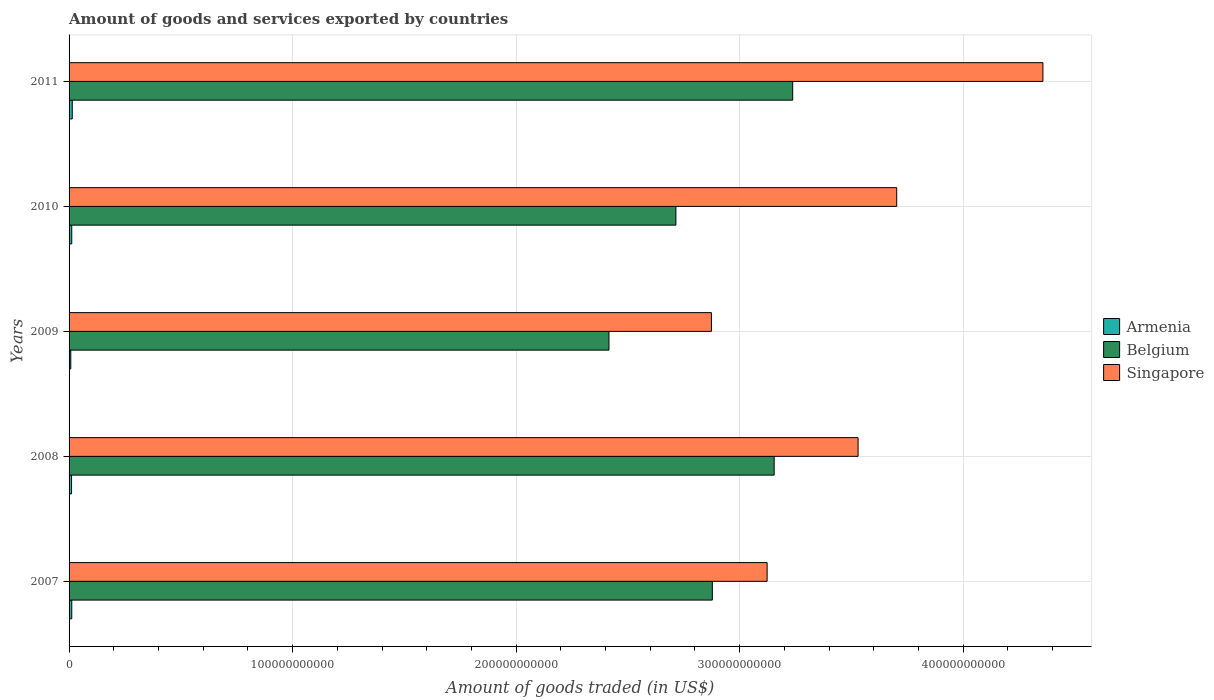How many groups of bars are there?
Keep it short and to the point. 5. Are the number of bars per tick equal to the number of legend labels?
Offer a terse response. Yes. How many bars are there on the 5th tick from the top?
Your answer should be very brief. 3. How many bars are there on the 3rd tick from the bottom?
Provide a short and direct response. 3. What is the total amount of goods and services exported in Belgium in 2008?
Keep it short and to the point. 3.15e+11. Across all years, what is the maximum total amount of goods and services exported in Armenia?
Ensure brevity in your answer.  1.43e+09. Across all years, what is the minimum total amount of goods and services exported in Singapore?
Offer a terse response. 2.87e+11. In which year was the total amount of goods and services exported in Belgium maximum?
Ensure brevity in your answer.  2011. In which year was the total amount of goods and services exported in Belgium minimum?
Provide a succinct answer. 2009. What is the total total amount of goods and services exported in Singapore in the graph?
Your answer should be compact. 1.76e+12. What is the difference between the total amount of goods and services exported in Belgium in 2008 and that in 2010?
Give a very brief answer. 4.40e+1. What is the difference between the total amount of goods and services exported in Armenia in 2010 and the total amount of goods and services exported in Singapore in 2007?
Your answer should be very brief. -3.11e+11. What is the average total amount of goods and services exported in Singapore per year?
Ensure brevity in your answer.  3.52e+11. In the year 2007, what is the difference between the total amount of goods and services exported in Belgium and total amount of goods and services exported in Singapore?
Your response must be concise. -2.45e+1. What is the ratio of the total amount of goods and services exported in Singapore in 2010 to that in 2011?
Provide a succinct answer. 0.85. Is the total amount of goods and services exported in Armenia in 2007 less than that in 2008?
Make the answer very short. No. Is the difference between the total amount of goods and services exported in Belgium in 2009 and 2010 greater than the difference between the total amount of goods and services exported in Singapore in 2009 and 2010?
Your answer should be compact. Yes. What is the difference between the highest and the second highest total amount of goods and services exported in Armenia?
Your response must be concise. 2.27e+08. What is the difference between the highest and the lowest total amount of goods and services exported in Singapore?
Keep it short and to the point. 1.48e+11. Is the sum of the total amount of goods and services exported in Belgium in 2009 and 2010 greater than the maximum total amount of goods and services exported in Singapore across all years?
Keep it short and to the point. Yes. What does the 2nd bar from the top in 2009 represents?
Make the answer very short. Belgium. What does the 3rd bar from the bottom in 2008 represents?
Keep it short and to the point. Singapore. Are all the bars in the graph horizontal?
Provide a short and direct response. Yes. What is the difference between two consecutive major ticks on the X-axis?
Offer a terse response. 1.00e+11. Are the values on the major ticks of X-axis written in scientific E-notation?
Your answer should be compact. No. Does the graph contain any zero values?
Provide a short and direct response. No. Does the graph contain grids?
Offer a very short reply. Yes. Where does the legend appear in the graph?
Provide a short and direct response. Center right. How many legend labels are there?
Offer a very short reply. 3. How are the legend labels stacked?
Ensure brevity in your answer.  Vertical. What is the title of the graph?
Offer a very short reply. Amount of goods and services exported by countries. What is the label or title of the X-axis?
Provide a short and direct response. Amount of goods traded (in US$). What is the Amount of goods traded (in US$) of Armenia in 2007?
Keep it short and to the point. 1.20e+09. What is the Amount of goods traded (in US$) in Belgium in 2007?
Your answer should be compact. 2.88e+11. What is the Amount of goods traded (in US$) of Singapore in 2007?
Make the answer very short. 3.12e+11. What is the Amount of goods traded (in US$) in Armenia in 2008?
Provide a succinct answer. 1.11e+09. What is the Amount of goods traded (in US$) of Belgium in 2008?
Keep it short and to the point. 3.15e+11. What is the Amount of goods traded (in US$) of Singapore in 2008?
Your response must be concise. 3.53e+11. What is the Amount of goods traded (in US$) in Armenia in 2009?
Your answer should be compact. 7.74e+08. What is the Amount of goods traded (in US$) of Belgium in 2009?
Give a very brief answer. 2.42e+11. What is the Amount of goods traded (in US$) in Singapore in 2009?
Offer a terse response. 2.87e+11. What is the Amount of goods traded (in US$) in Armenia in 2010?
Your response must be concise. 1.20e+09. What is the Amount of goods traded (in US$) of Belgium in 2010?
Offer a very short reply. 2.71e+11. What is the Amount of goods traded (in US$) of Singapore in 2010?
Offer a very short reply. 3.70e+11. What is the Amount of goods traded (in US$) of Armenia in 2011?
Offer a terse response. 1.43e+09. What is the Amount of goods traded (in US$) of Belgium in 2011?
Offer a terse response. 3.24e+11. What is the Amount of goods traded (in US$) of Singapore in 2011?
Make the answer very short. 4.36e+11. Across all years, what is the maximum Amount of goods traded (in US$) in Armenia?
Give a very brief answer. 1.43e+09. Across all years, what is the maximum Amount of goods traded (in US$) in Belgium?
Make the answer very short. 3.24e+11. Across all years, what is the maximum Amount of goods traded (in US$) of Singapore?
Offer a very short reply. 4.36e+11. Across all years, what is the minimum Amount of goods traded (in US$) in Armenia?
Offer a terse response. 7.74e+08. Across all years, what is the minimum Amount of goods traded (in US$) of Belgium?
Offer a very short reply. 2.42e+11. Across all years, what is the minimum Amount of goods traded (in US$) in Singapore?
Your answer should be compact. 2.87e+11. What is the total Amount of goods traded (in US$) of Armenia in the graph?
Make the answer very short. 5.71e+09. What is the total Amount of goods traded (in US$) of Belgium in the graph?
Ensure brevity in your answer.  1.44e+12. What is the total Amount of goods traded (in US$) in Singapore in the graph?
Your response must be concise. 1.76e+12. What is the difference between the Amount of goods traded (in US$) in Armenia in 2007 and that in 2008?
Offer a terse response. 9.79e+07. What is the difference between the Amount of goods traded (in US$) of Belgium in 2007 and that in 2008?
Your answer should be very brief. -2.77e+1. What is the difference between the Amount of goods traded (in US$) of Singapore in 2007 and that in 2008?
Keep it short and to the point. -4.07e+1. What is the difference between the Amount of goods traded (in US$) in Armenia in 2007 and that in 2009?
Ensure brevity in your answer.  4.31e+08. What is the difference between the Amount of goods traded (in US$) in Belgium in 2007 and that in 2009?
Keep it short and to the point. 4.62e+1. What is the difference between the Amount of goods traded (in US$) in Singapore in 2007 and that in 2009?
Provide a succinct answer. 2.49e+1. What is the difference between the Amount of goods traded (in US$) in Armenia in 2007 and that in 2010?
Give a very brief answer. 6.75e+06. What is the difference between the Amount of goods traded (in US$) of Belgium in 2007 and that in 2010?
Your response must be concise. 1.63e+1. What is the difference between the Amount of goods traded (in US$) of Singapore in 2007 and that in 2010?
Make the answer very short. -5.80e+1. What is the difference between the Amount of goods traded (in US$) of Armenia in 2007 and that in 2011?
Ensure brevity in your answer.  -2.27e+08. What is the difference between the Amount of goods traded (in US$) of Belgium in 2007 and that in 2011?
Provide a short and direct response. -3.60e+1. What is the difference between the Amount of goods traded (in US$) of Singapore in 2007 and that in 2011?
Ensure brevity in your answer.  -1.23e+11. What is the difference between the Amount of goods traded (in US$) in Armenia in 2008 and that in 2009?
Make the answer very short. 3.33e+08. What is the difference between the Amount of goods traded (in US$) in Belgium in 2008 and that in 2009?
Your response must be concise. 7.39e+1. What is the difference between the Amount of goods traded (in US$) of Singapore in 2008 and that in 2009?
Offer a very short reply. 6.56e+1. What is the difference between the Amount of goods traded (in US$) of Armenia in 2008 and that in 2010?
Offer a very short reply. -9.12e+07. What is the difference between the Amount of goods traded (in US$) in Belgium in 2008 and that in 2010?
Ensure brevity in your answer.  4.40e+1. What is the difference between the Amount of goods traded (in US$) of Singapore in 2008 and that in 2010?
Provide a short and direct response. -1.73e+1. What is the difference between the Amount of goods traded (in US$) of Armenia in 2008 and that in 2011?
Offer a terse response. -3.25e+08. What is the difference between the Amount of goods traded (in US$) in Belgium in 2008 and that in 2011?
Your response must be concise. -8.30e+09. What is the difference between the Amount of goods traded (in US$) of Singapore in 2008 and that in 2011?
Provide a short and direct response. -8.27e+1. What is the difference between the Amount of goods traded (in US$) in Armenia in 2009 and that in 2010?
Provide a succinct answer. -4.24e+08. What is the difference between the Amount of goods traded (in US$) of Belgium in 2009 and that in 2010?
Provide a short and direct response. -3.00e+1. What is the difference between the Amount of goods traded (in US$) of Singapore in 2009 and that in 2010?
Your answer should be very brief. -8.29e+1. What is the difference between the Amount of goods traded (in US$) in Armenia in 2009 and that in 2011?
Ensure brevity in your answer.  -6.58e+08. What is the difference between the Amount of goods traded (in US$) of Belgium in 2009 and that in 2011?
Your answer should be compact. -8.22e+1. What is the difference between the Amount of goods traded (in US$) of Singapore in 2009 and that in 2011?
Make the answer very short. -1.48e+11. What is the difference between the Amount of goods traded (in US$) of Armenia in 2010 and that in 2011?
Your answer should be compact. -2.34e+08. What is the difference between the Amount of goods traded (in US$) of Belgium in 2010 and that in 2011?
Offer a terse response. -5.22e+1. What is the difference between the Amount of goods traded (in US$) of Singapore in 2010 and that in 2011?
Ensure brevity in your answer.  -6.54e+1. What is the difference between the Amount of goods traded (in US$) in Armenia in 2007 and the Amount of goods traded (in US$) in Belgium in 2008?
Give a very brief answer. -3.14e+11. What is the difference between the Amount of goods traded (in US$) of Armenia in 2007 and the Amount of goods traded (in US$) of Singapore in 2008?
Provide a short and direct response. -3.52e+11. What is the difference between the Amount of goods traded (in US$) of Belgium in 2007 and the Amount of goods traded (in US$) of Singapore in 2008?
Provide a succinct answer. -6.52e+1. What is the difference between the Amount of goods traded (in US$) of Armenia in 2007 and the Amount of goods traded (in US$) of Belgium in 2009?
Your answer should be compact. -2.40e+11. What is the difference between the Amount of goods traded (in US$) of Armenia in 2007 and the Amount of goods traded (in US$) of Singapore in 2009?
Your response must be concise. -2.86e+11. What is the difference between the Amount of goods traded (in US$) of Belgium in 2007 and the Amount of goods traded (in US$) of Singapore in 2009?
Provide a short and direct response. 4.09e+08. What is the difference between the Amount of goods traded (in US$) in Armenia in 2007 and the Amount of goods traded (in US$) in Belgium in 2010?
Your answer should be compact. -2.70e+11. What is the difference between the Amount of goods traded (in US$) of Armenia in 2007 and the Amount of goods traded (in US$) of Singapore in 2010?
Provide a short and direct response. -3.69e+11. What is the difference between the Amount of goods traded (in US$) in Belgium in 2007 and the Amount of goods traded (in US$) in Singapore in 2010?
Your answer should be compact. -8.25e+1. What is the difference between the Amount of goods traded (in US$) in Armenia in 2007 and the Amount of goods traded (in US$) in Belgium in 2011?
Offer a very short reply. -3.23e+11. What is the difference between the Amount of goods traded (in US$) in Armenia in 2007 and the Amount of goods traded (in US$) in Singapore in 2011?
Give a very brief answer. -4.34e+11. What is the difference between the Amount of goods traded (in US$) in Belgium in 2007 and the Amount of goods traded (in US$) in Singapore in 2011?
Provide a succinct answer. -1.48e+11. What is the difference between the Amount of goods traded (in US$) of Armenia in 2008 and the Amount of goods traded (in US$) of Belgium in 2009?
Your response must be concise. -2.40e+11. What is the difference between the Amount of goods traded (in US$) of Armenia in 2008 and the Amount of goods traded (in US$) of Singapore in 2009?
Make the answer very short. -2.86e+11. What is the difference between the Amount of goods traded (in US$) of Belgium in 2008 and the Amount of goods traded (in US$) of Singapore in 2009?
Ensure brevity in your answer.  2.81e+1. What is the difference between the Amount of goods traded (in US$) in Armenia in 2008 and the Amount of goods traded (in US$) in Belgium in 2010?
Make the answer very short. -2.70e+11. What is the difference between the Amount of goods traded (in US$) of Armenia in 2008 and the Amount of goods traded (in US$) of Singapore in 2010?
Provide a short and direct response. -3.69e+11. What is the difference between the Amount of goods traded (in US$) of Belgium in 2008 and the Amount of goods traded (in US$) of Singapore in 2010?
Your answer should be very brief. -5.48e+1. What is the difference between the Amount of goods traded (in US$) of Armenia in 2008 and the Amount of goods traded (in US$) of Belgium in 2011?
Provide a succinct answer. -3.23e+11. What is the difference between the Amount of goods traded (in US$) in Armenia in 2008 and the Amount of goods traded (in US$) in Singapore in 2011?
Offer a very short reply. -4.35e+11. What is the difference between the Amount of goods traded (in US$) in Belgium in 2008 and the Amount of goods traded (in US$) in Singapore in 2011?
Offer a terse response. -1.20e+11. What is the difference between the Amount of goods traded (in US$) of Armenia in 2009 and the Amount of goods traded (in US$) of Belgium in 2010?
Provide a short and direct response. -2.71e+11. What is the difference between the Amount of goods traded (in US$) in Armenia in 2009 and the Amount of goods traded (in US$) in Singapore in 2010?
Offer a terse response. -3.69e+11. What is the difference between the Amount of goods traded (in US$) of Belgium in 2009 and the Amount of goods traded (in US$) of Singapore in 2010?
Keep it short and to the point. -1.29e+11. What is the difference between the Amount of goods traded (in US$) of Armenia in 2009 and the Amount of goods traded (in US$) of Belgium in 2011?
Your answer should be very brief. -3.23e+11. What is the difference between the Amount of goods traded (in US$) in Armenia in 2009 and the Amount of goods traded (in US$) in Singapore in 2011?
Offer a very short reply. -4.35e+11. What is the difference between the Amount of goods traded (in US$) of Belgium in 2009 and the Amount of goods traded (in US$) of Singapore in 2011?
Provide a short and direct response. -1.94e+11. What is the difference between the Amount of goods traded (in US$) of Armenia in 2010 and the Amount of goods traded (in US$) of Belgium in 2011?
Make the answer very short. -3.23e+11. What is the difference between the Amount of goods traded (in US$) of Armenia in 2010 and the Amount of goods traded (in US$) of Singapore in 2011?
Give a very brief answer. -4.34e+11. What is the difference between the Amount of goods traded (in US$) in Belgium in 2010 and the Amount of goods traded (in US$) in Singapore in 2011?
Provide a short and direct response. -1.64e+11. What is the average Amount of goods traded (in US$) of Armenia per year?
Make the answer very short. 1.14e+09. What is the average Amount of goods traded (in US$) of Belgium per year?
Give a very brief answer. 2.88e+11. What is the average Amount of goods traded (in US$) of Singapore per year?
Your response must be concise. 3.52e+11. In the year 2007, what is the difference between the Amount of goods traded (in US$) in Armenia and Amount of goods traded (in US$) in Belgium?
Keep it short and to the point. -2.87e+11. In the year 2007, what is the difference between the Amount of goods traded (in US$) in Armenia and Amount of goods traded (in US$) in Singapore?
Your answer should be compact. -3.11e+11. In the year 2007, what is the difference between the Amount of goods traded (in US$) of Belgium and Amount of goods traded (in US$) of Singapore?
Ensure brevity in your answer.  -2.45e+1. In the year 2008, what is the difference between the Amount of goods traded (in US$) in Armenia and Amount of goods traded (in US$) in Belgium?
Ensure brevity in your answer.  -3.14e+11. In the year 2008, what is the difference between the Amount of goods traded (in US$) in Armenia and Amount of goods traded (in US$) in Singapore?
Your answer should be compact. -3.52e+11. In the year 2008, what is the difference between the Amount of goods traded (in US$) of Belgium and Amount of goods traded (in US$) of Singapore?
Keep it short and to the point. -3.75e+1. In the year 2009, what is the difference between the Amount of goods traded (in US$) in Armenia and Amount of goods traded (in US$) in Belgium?
Give a very brief answer. -2.41e+11. In the year 2009, what is the difference between the Amount of goods traded (in US$) in Armenia and Amount of goods traded (in US$) in Singapore?
Provide a short and direct response. -2.87e+11. In the year 2009, what is the difference between the Amount of goods traded (in US$) of Belgium and Amount of goods traded (in US$) of Singapore?
Provide a short and direct response. -4.58e+1. In the year 2010, what is the difference between the Amount of goods traded (in US$) in Armenia and Amount of goods traded (in US$) in Belgium?
Provide a succinct answer. -2.70e+11. In the year 2010, what is the difference between the Amount of goods traded (in US$) of Armenia and Amount of goods traded (in US$) of Singapore?
Keep it short and to the point. -3.69e+11. In the year 2010, what is the difference between the Amount of goods traded (in US$) in Belgium and Amount of goods traded (in US$) in Singapore?
Make the answer very short. -9.88e+1. In the year 2011, what is the difference between the Amount of goods traded (in US$) in Armenia and Amount of goods traded (in US$) in Belgium?
Make the answer very short. -3.22e+11. In the year 2011, what is the difference between the Amount of goods traded (in US$) in Armenia and Amount of goods traded (in US$) in Singapore?
Offer a very short reply. -4.34e+11. In the year 2011, what is the difference between the Amount of goods traded (in US$) of Belgium and Amount of goods traded (in US$) of Singapore?
Give a very brief answer. -1.12e+11. What is the ratio of the Amount of goods traded (in US$) of Armenia in 2007 to that in 2008?
Provide a short and direct response. 1.09. What is the ratio of the Amount of goods traded (in US$) of Belgium in 2007 to that in 2008?
Ensure brevity in your answer.  0.91. What is the ratio of the Amount of goods traded (in US$) in Singapore in 2007 to that in 2008?
Provide a short and direct response. 0.88. What is the ratio of the Amount of goods traded (in US$) in Armenia in 2007 to that in 2009?
Your response must be concise. 1.56. What is the ratio of the Amount of goods traded (in US$) in Belgium in 2007 to that in 2009?
Provide a short and direct response. 1.19. What is the ratio of the Amount of goods traded (in US$) in Singapore in 2007 to that in 2009?
Offer a terse response. 1.09. What is the ratio of the Amount of goods traded (in US$) of Armenia in 2007 to that in 2010?
Provide a short and direct response. 1.01. What is the ratio of the Amount of goods traded (in US$) of Belgium in 2007 to that in 2010?
Offer a terse response. 1.06. What is the ratio of the Amount of goods traded (in US$) in Singapore in 2007 to that in 2010?
Make the answer very short. 0.84. What is the ratio of the Amount of goods traded (in US$) of Armenia in 2007 to that in 2011?
Your response must be concise. 0.84. What is the ratio of the Amount of goods traded (in US$) of Belgium in 2007 to that in 2011?
Provide a short and direct response. 0.89. What is the ratio of the Amount of goods traded (in US$) of Singapore in 2007 to that in 2011?
Keep it short and to the point. 0.72. What is the ratio of the Amount of goods traded (in US$) of Armenia in 2008 to that in 2009?
Your response must be concise. 1.43. What is the ratio of the Amount of goods traded (in US$) in Belgium in 2008 to that in 2009?
Provide a short and direct response. 1.31. What is the ratio of the Amount of goods traded (in US$) in Singapore in 2008 to that in 2009?
Offer a very short reply. 1.23. What is the ratio of the Amount of goods traded (in US$) in Armenia in 2008 to that in 2010?
Your answer should be compact. 0.92. What is the ratio of the Amount of goods traded (in US$) in Belgium in 2008 to that in 2010?
Your answer should be compact. 1.16. What is the ratio of the Amount of goods traded (in US$) of Singapore in 2008 to that in 2010?
Your response must be concise. 0.95. What is the ratio of the Amount of goods traded (in US$) in Armenia in 2008 to that in 2011?
Keep it short and to the point. 0.77. What is the ratio of the Amount of goods traded (in US$) in Belgium in 2008 to that in 2011?
Offer a very short reply. 0.97. What is the ratio of the Amount of goods traded (in US$) of Singapore in 2008 to that in 2011?
Offer a terse response. 0.81. What is the ratio of the Amount of goods traded (in US$) in Armenia in 2009 to that in 2010?
Offer a very short reply. 0.65. What is the ratio of the Amount of goods traded (in US$) in Belgium in 2009 to that in 2010?
Make the answer very short. 0.89. What is the ratio of the Amount of goods traded (in US$) of Singapore in 2009 to that in 2010?
Your answer should be compact. 0.78. What is the ratio of the Amount of goods traded (in US$) of Armenia in 2009 to that in 2011?
Ensure brevity in your answer.  0.54. What is the ratio of the Amount of goods traded (in US$) of Belgium in 2009 to that in 2011?
Make the answer very short. 0.75. What is the ratio of the Amount of goods traded (in US$) in Singapore in 2009 to that in 2011?
Offer a very short reply. 0.66. What is the ratio of the Amount of goods traded (in US$) in Armenia in 2010 to that in 2011?
Offer a very short reply. 0.84. What is the ratio of the Amount of goods traded (in US$) of Belgium in 2010 to that in 2011?
Offer a very short reply. 0.84. What is the ratio of the Amount of goods traded (in US$) of Singapore in 2010 to that in 2011?
Provide a succinct answer. 0.85. What is the difference between the highest and the second highest Amount of goods traded (in US$) of Armenia?
Give a very brief answer. 2.27e+08. What is the difference between the highest and the second highest Amount of goods traded (in US$) in Belgium?
Provide a short and direct response. 8.30e+09. What is the difference between the highest and the second highest Amount of goods traded (in US$) of Singapore?
Provide a short and direct response. 6.54e+1. What is the difference between the highest and the lowest Amount of goods traded (in US$) of Armenia?
Offer a very short reply. 6.58e+08. What is the difference between the highest and the lowest Amount of goods traded (in US$) in Belgium?
Make the answer very short. 8.22e+1. What is the difference between the highest and the lowest Amount of goods traded (in US$) of Singapore?
Offer a very short reply. 1.48e+11. 